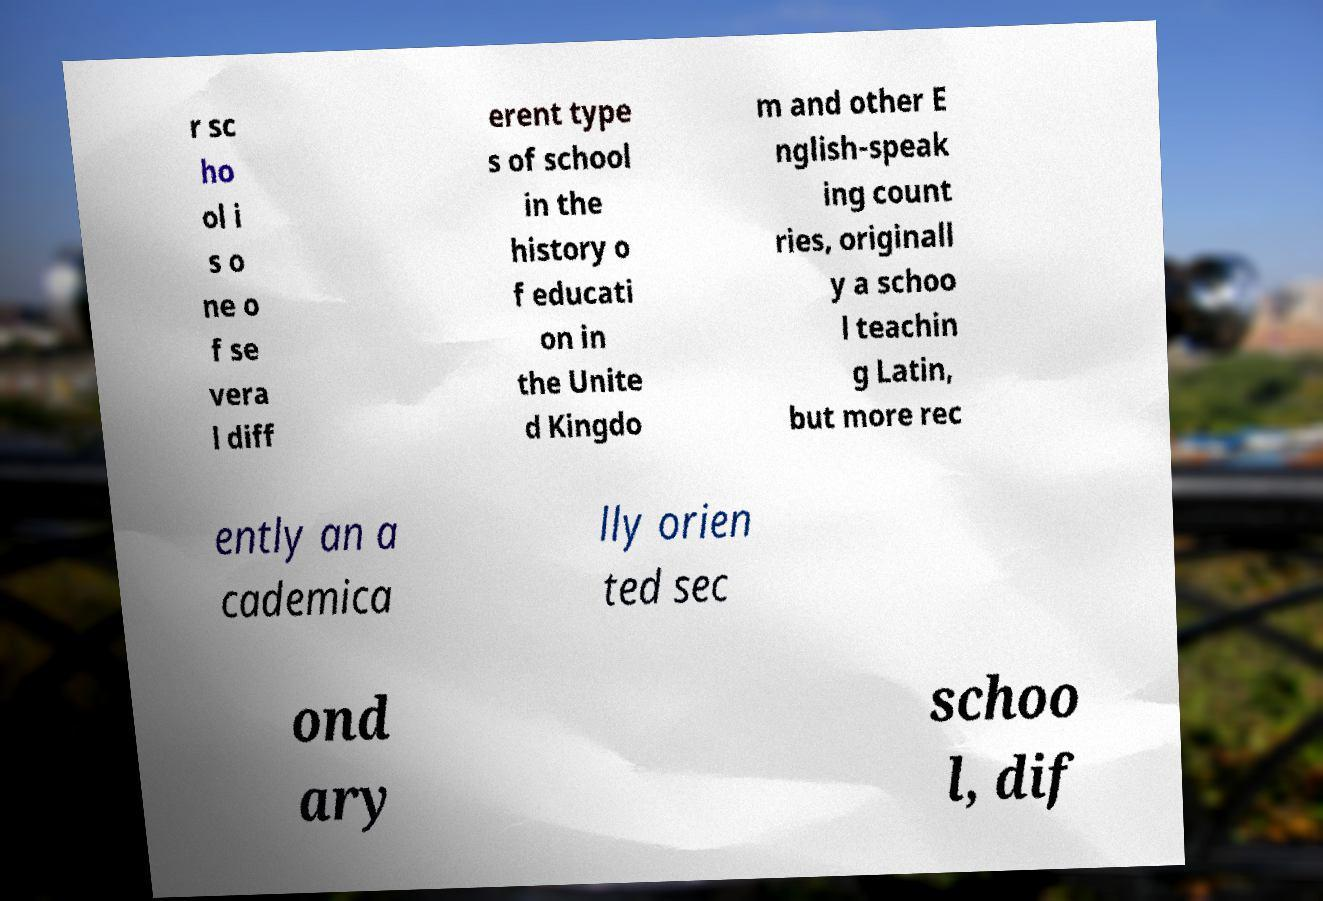For documentation purposes, I need the text within this image transcribed. Could you provide that? r sc ho ol i s o ne o f se vera l diff erent type s of school in the history o f educati on in the Unite d Kingdo m and other E nglish-speak ing count ries, originall y a schoo l teachin g Latin, but more rec ently an a cademica lly orien ted sec ond ary schoo l, dif 